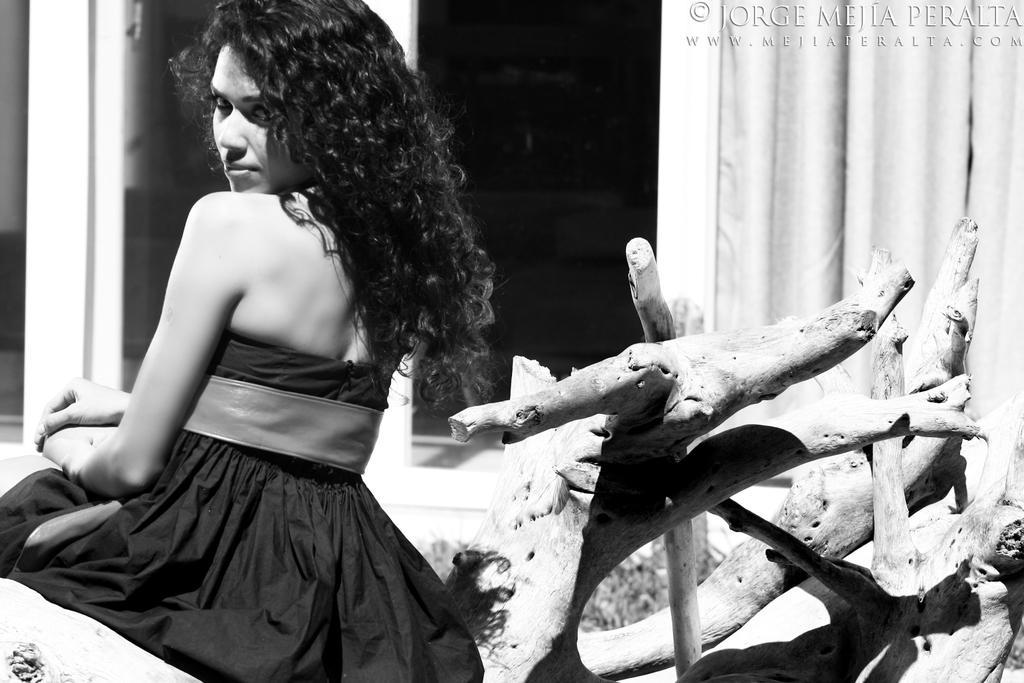Please provide a concise description of this image. In this image in the left a lady is sitting wearing black dress. She is sitting on a wood. In the background there are curtains. 